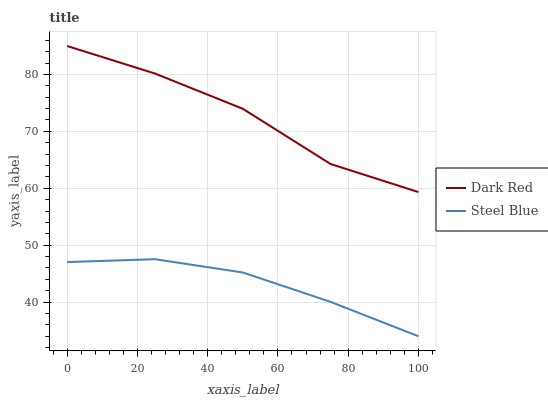Does Steel Blue have the minimum area under the curve?
Answer yes or no. Yes. Does Dark Red have the maximum area under the curve?
Answer yes or no. Yes. Does Steel Blue have the maximum area under the curve?
Answer yes or no. No. Is Steel Blue the smoothest?
Answer yes or no. Yes. Is Dark Red the roughest?
Answer yes or no. Yes. Is Steel Blue the roughest?
Answer yes or no. No. Does Steel Blue have the lowest value?
Answer yes or no. Yes. Does Dark Red have the highest value?
Answer yes or no. Yes. Does Steel Blue have the highest value?
Answer yes or no. No. Is Steel Blue less than Dark Red?
Answer yes or no. Yes. Is Dark Red greater than Steel Blue?
Answer yes or no. Yes. Does Steel Blue intersect Dark Red?
Answer yes or no. No. 